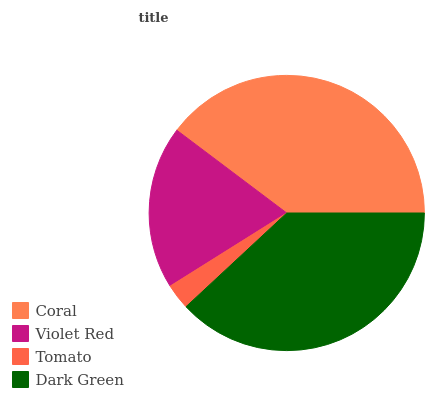Is Tomato the minimum?
Answer yes or no. Yes. Is Coral the maximum?
Answer yes or no. Yes. Is Violet Red the minimum?
Answer yes or no. No. Is Violet Red the maximum?
Answer yes or no. No. Is Coral greater than Violet Red?
Answer yes or no. Yes. Is Violet Red less than Coral?
Answer yes or no. Yes. Is Violet Red greater than Coral?
Answer yes or no. No. Is Coral less than Violet Red?
Answer yes or no. No. Is Dark Green the high median?
Answer yes or no. Yes. Is Violet Red the low median?
Answer yes or no. Yes. Is Tomato the high median?
Answer yes or no. No. Is Tomato the low median?
Answer yes or no. No. 